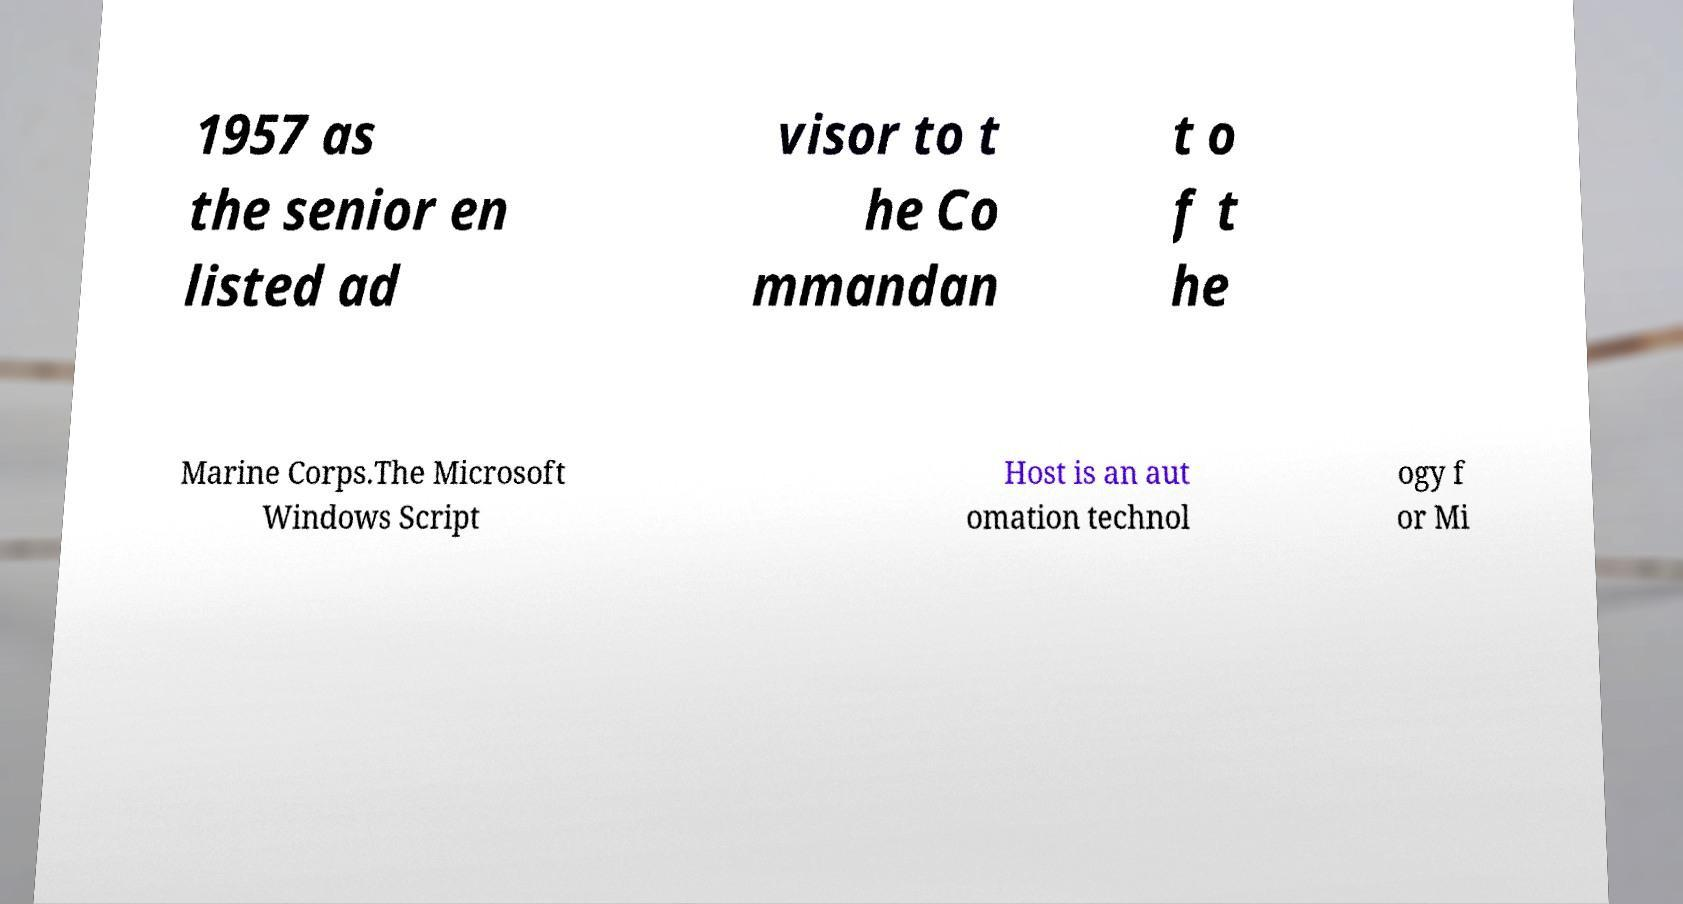Please identify and transcribe the text found in this image. 1957 as the senior en listed ad visor to t he Co mmandan t o f t he Marine Corps.The Microsoft Windows Script Host is an aut omation technol ogy f or Mi 